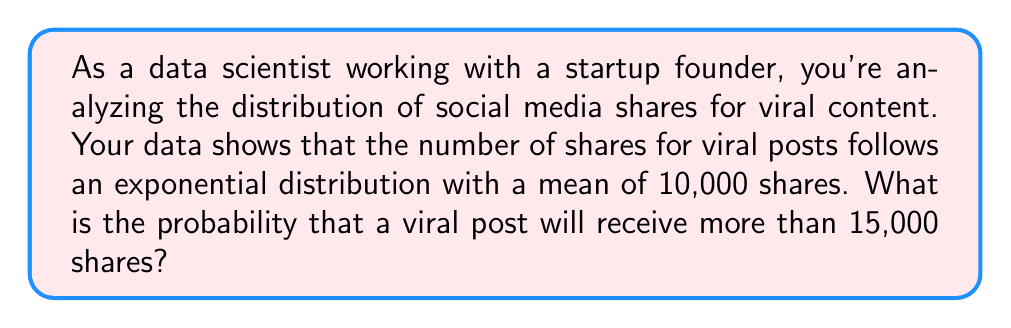Show me your answer to this math problem. To solve this problem, we need to use the properties of the exponential distribution and its cumulative distribution function (CDF).

1. For an exponential distribution, the probability density function (PDF) is given by:
   $$f(x) = \lambda e^{-\lambda x}$$
   where $\lambda$ is the rate parameter.

2. The mean of an exponential distribution is $\frac{1}{\lambda}$. Given that the mean is 10,000 shares, we can calculate $\lambda$:
   $$\frac{1}{\lambda} = 10,000$$
   $$\lambda = \frac{1}{10,000} = 0.0001$$

3. We want to find the probability that a viral post will receive more than 15,000 shares. This is equivalent to finding the complement of the cumulative distribution function (CDF) at x = 15,000.

4. The CDF of an exponential distribution is given by:
   $$F(x) = 1 - e^{-\lambda x}$$

5. The probability we're looking for is:
   $$P(X > 15000) = 1 - P(X \leq 15000) = 1 - F(15000)$$

6. Substituting the values:
   $$P(X > 15000) = 1 - (1 - e^{-0.0001 \cdot 15000})$$
   $$= e^{-0.0001 \cdot 15000}$$
   $$= e^{-1.5}$$

7. Calculate the final result:
   $$e^{-1.5} \approx 0.2231$$

Therefore, the probability that a viral post will receive more than 15,000 shares is approximately 0.2231 or 22.31%.
Answer: The probability that a viral post will receive more than 15,000 shares is approximately 0.2231 or 22.31%. 